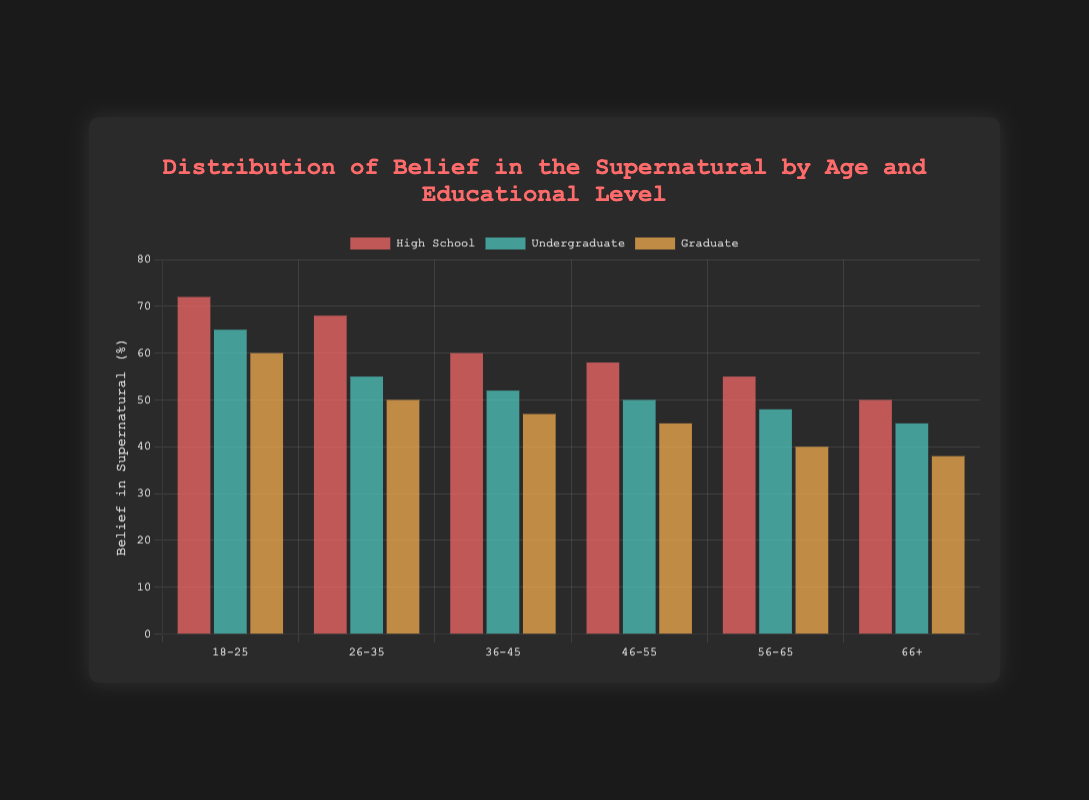What age group has the highest belief in the supernatural for those with a high school education? By looking at the chart, we can see that the highest belief percentage for high school educated individuals is in the 18-25 age group.
Answer: 18-25 Which educational level shows the greatest drop in belief in the supernatural from the 18-25 age group to the 66+ age group? The belief in the supernatural for high school drops from 72 to 50, undergraduate drops from 65 to 45, and graduate drops from 60 to 38. The greatest drop is seen in those with a high school education, dropping by 22 percentage points.
Answer: High School How does the belief in the supernatural compare between the 26-35 age group with an undergraduate degree and the 56-65 age group with a high school education? The belief percentage for the 26-35 age group with an undergraduate degree is 55%, while it is 55% for the 56-65 age group with a high school education. Both these values are equal.
Answer: Equal What is the average belief in the supernatural for the three educational levels within the 36-45 age group? The belief percentages for high school, undergraduate, and graduate within the 36-45 age group are 60, 52, and 47 respectively. The average is calculated as (60 + 52 + 47) / 3 = 53.
Answer: 53 Which color represents the undergraduate educational level in the chart? The chart shows three colors: red, green, and orange. By matching each color to their respective labels, the undergraduate level is represented by green.
Answer: Green 